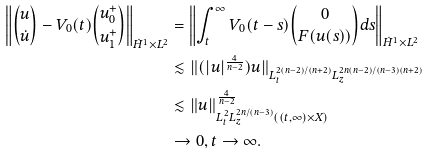<formula> <loc_0><loc_0><loc_500><loc_500>\left \| { u \choose \dot { u } } - V _ { 0 } ( t ) { u _ { 0 } ^ { + } \choose u _ { 1 } ^ { + } } \right \| _ { \dot { H } ^ { 1 } \times L ^ { 2 } } & = \left \| \int _ { t } ^ { \infty } V _ { 0 } ( t - s ) { 0 \choose F ( u ( s ) ) } d s \right \| _ { \dot { H } ^ { 1 } \times L ^ { 2 } } \\ & \lesssim \| ( | u | ^ { \frac { 4 } { n - 2 } } ) u \| _ { L _ { t } ^ { 2 ( n - 2 ) / ( n + 2 ) } L _ { z } ^ { 2 n ( n - 2 ) / ( n - 3 ) ( n + 2 ) } } \\ & \lesssim \| u \| _ { L _ { t } ^ { 2 } L _ { z } ^ { 2 n / ( n - 3 ) } ( ( t , \infty ) \times X ) } ^ { \frac { 4 } { n - 2 } } \\ & \rightarrow 0 , t \rightarrow \infty .</formula> 